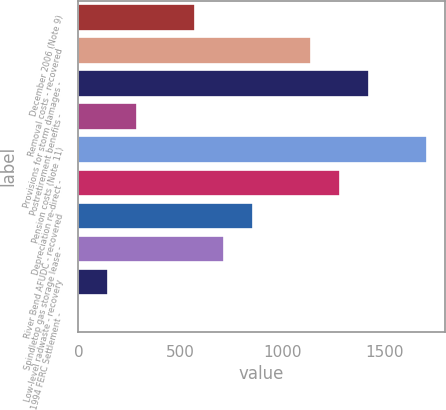Convert chart to OTSL. <chart><loc_0><loc_0><loc_500><loc_500><bar_chart><fcel>December 2006 (Note 9)<fcel>Removal costs - recovered<fcel>Provisions for storm damages -<fcel>Postretirement benefits -<fcel>Pension costs (Note 11)<fcel>Depreciation re-direct -<fcel>River Bend AFUDC - recovered<fcel>Spindletop gas storage lease -<fcel>Low-level radwaste - recovery<fcel>1994 FERC Settlement -<nl><fcel>572.44<fcel>1140.88<fcel>1425.1<fcel>288.22<fcel>1709.32<fcel>1282.99<fcel>856.66<fcel>714.55<fcel>146.11<fcel>4<nl></chart> 